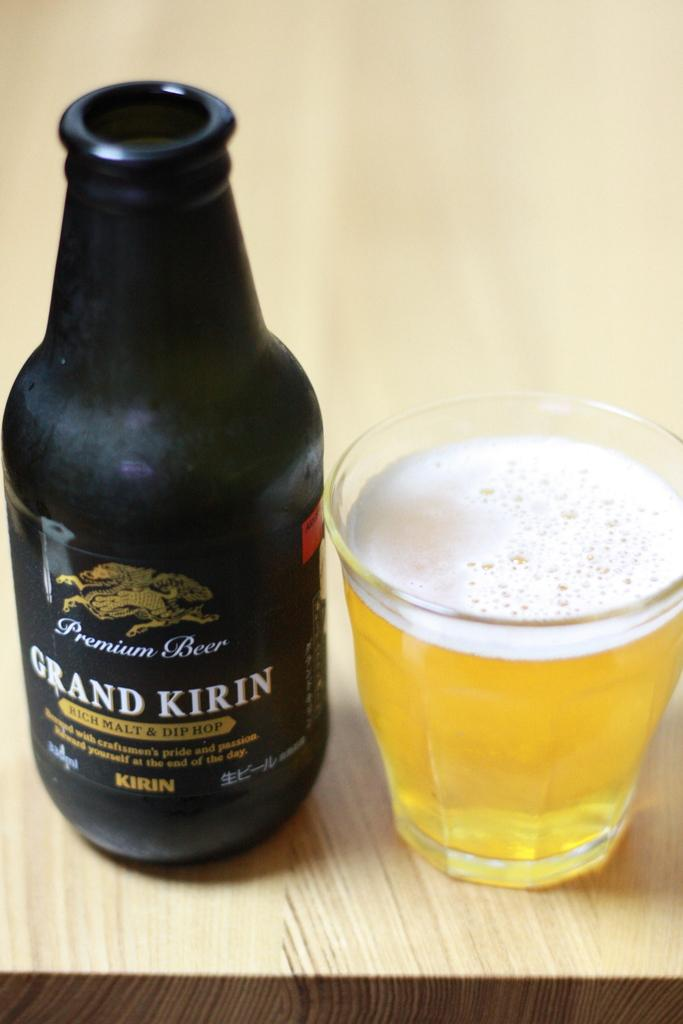<image>
Create a compact narrative representing the image presented. Dark Grand Kirin Premium Beer bottle next to a cup of beer. 